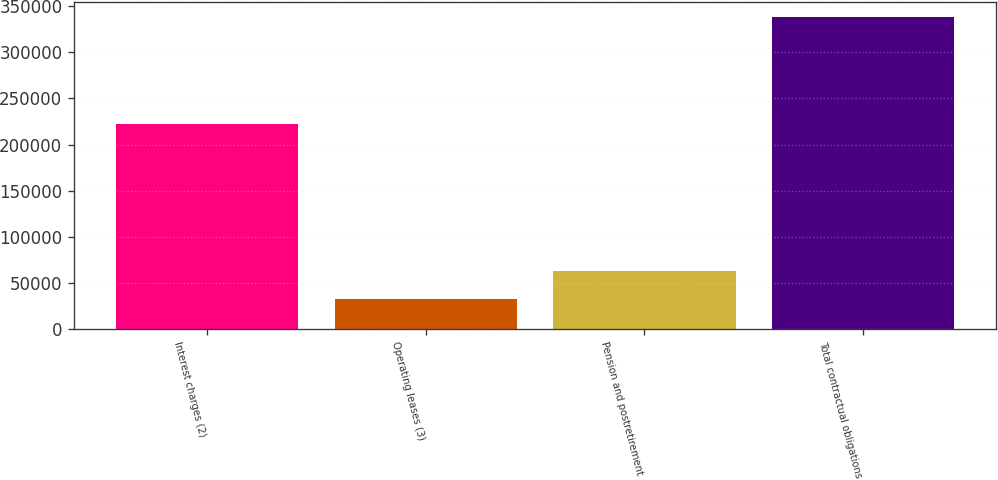<chart> <loc_0><loc_0><loc_500><loc_500><bar_chart><fcel>Interest charges (2)<fcel>Operating leases (3)<fcel>Pension and postretirement<fcel>Total contractual obligations<nl><fcel>222759<fcel>32685<fcel>63222.5<fcel>338060<nl></chart> 